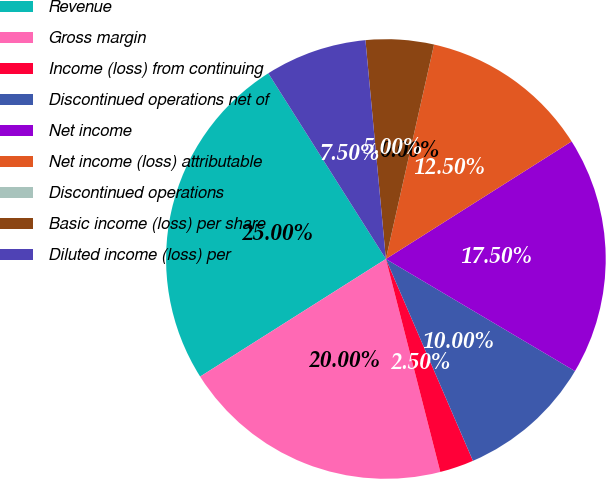Convert chart to OTSL. <chart><loc_0><loc_0><loc_500><loc_500><pie_chart><fcel>Revenue<fcel>Gross margin<fcel>Income (loss) from continuing<fcel>Discontinued operations net of<fcel>Net income<fcel>Net income (loss) attributable<fcel>Discontinued operations<fcel>Basic income (loss) per share<fcel>Diluted income (loss) per<nl><fcel>25.0%<fcel>20.0%<fcel>2.5%<fcel>10.0%<fcel>17.5%<fcel>12.5%<fcel>0.0%<fcel>5.0%<fcel>7.5%<nl></chart> 